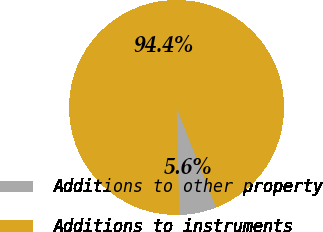Convert chart to OTSL. <chart><loc_0><loc_0><loc_500><loc_500><pie_chart><fcel>Additions to other property<fcel>Additions to instruments<nl><fcel>5.6%<fcel>94.4%<nl></chart> 